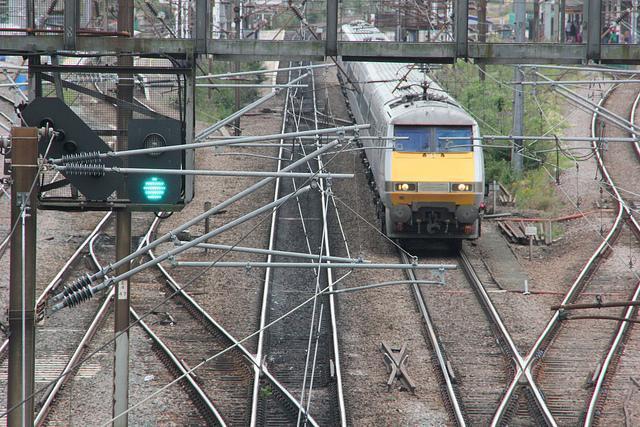The rightmost set of rails leads to which railway structure?
Select the accurate answer and provide justification: `Answer: choice
Rationale: srationale.`
Options: Workshop, depot, turntable, train station. Answer: train station.
Rationale: All trains need to end up at a train station. 